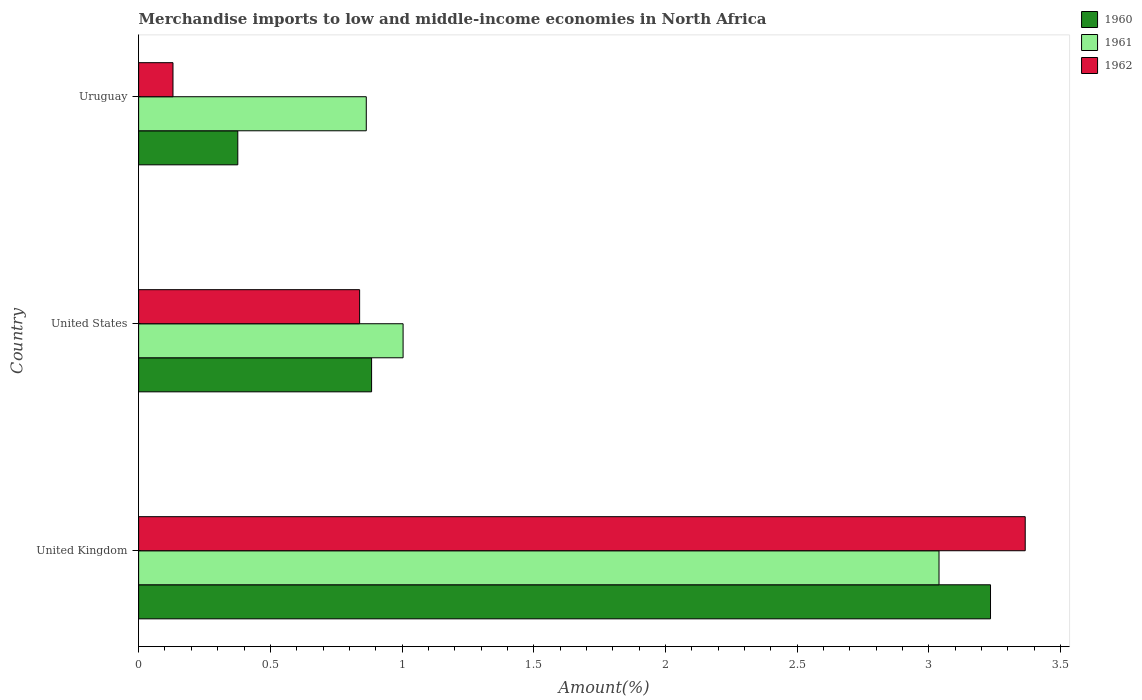How many different coloured bars are there?
Ensure brevity in your answer.  3. Are the number of bars per tick equal to the number of legend labels?
Offer a terse response. Yes. Are the number of bars on each tick of the Y-axis equal?
Provide a short and direct response. Yes. How many bars are there on the 1st tick from the top?
Keep it short and to the point. 3. How many bars are there on the 1st tick from the bottom?
Ensure brevity in your answer.  3. What is the label of the 1st group of bars from the top?
Keep it short and to the point. Uruguay. In how many cases, is the number of bars for a given country not equal to the number of legend labels?
Your response must be concise. 0. What is the percentage of amount earned from merchandise imports in 1962 in Uruguay?
Your answer should be compact. 0.13. Across all countries, what is the maximum percentage of amount earned from merchandise imports in 1962?
Give a very brief answer. 3.37. Across all countries, what is the minimum percentage of amount earned from merchandise imports in 1961?
Give a very brief answer. 0.86. In which country was the percentage of amount earned from merchandise imports in 1961 minimum?
Offer a terse response. Uruguay. What is the total percentage of amount earned from merchandise imports in 1962 in the graph?
Your answer should be compact. 4.33. What is the difference between the percentage of amount earned from merchandise imports in 1962 in United Kingdom and that in United States?
Your answer should be very brief. 2.53. What is the difference between the percentage of amount earned from merchandise imports in 1961 in United States and the percentage of amount earned from merchandise imports in 1962 in Uruguay?
Ensure brevity in your answer.  0.87. What is the average percentage of amount earned from merchandise imports in 1961 per country?
Provide a succinct answer. 1.64. What is the difference between the percentage of amount earned from merchandise imports in 1961 and percentage of amount earned from merchandise imports in 1960 in United Kingdom?
Offer a terse response. -0.2. What is the ratio of the percentage of amount earned from merchandise imports in 1960 in United Kingdom to that in United States?
Provide a short and direct response. 3.66. Is the percentage of amount earned from merchandise imports in 1962 in United Kingdom less than that in Uruguay?
Your answer should be very brief. No. What is the difference between the highest and the second highest percentage of amount earned from merchandise imports in 1960?
Offer a very short reply. 2.35. What is the difference between the highest and the lowest percentage of amount earned from merchandise imports in 1962?
Provide a succinct answer. 3.24. In how many countries, is the percentage of amount earned from merchandise imports in 1960 greater than the average percentage of amount earned from merchandise imports in 1960 taken over all countries?
Keep it short and to the point. 1. Is the sum of the percentage of amount earned from merchandise imports in 1961 in United Kingdom and Uruguay greater than the maximum percentage of amount earned from merchandise imports in 1962 across all countries?
Your answer should be very brief. Yes. How many bars are there?
Your answer should be very brief. 9. How many countries are there in the graph?
Provide a succinct answer. 3. What is the difference between two consecutive major ticks on the X-axis?
Your answer should be compact. 0.5. How many legend labels are there?
Make the answer very short. 3. What is the title of the graph?
Make the answer very short. Merchandise imports to low and middle-income economies in North Africa. Does "2000" appear as one of the legend labels in the graph?
Keep it short and to the point. No. What is the label or title of the X-axis?
Give a very brief answer. Amount(%). What is the Amount(%) in 1960 in United Kingdom?
Keep it short and to the point. 3.23. What is the Amount(%) in 1961 in United Kingdom?
Your response must be concise. 3.04. What is the Amount(%) of 1962 in United Kingdom?
Offer a terse response. 3.37. What is the Amount(%) in 1960 in United States?
Provide a succinct answer. 0.88. What is the Amount(%) of 1961 in United States?
Your response must be concise. 1. What is the Amount(%) of 1962 in United States?
Ensure brevity in your answer.  0.84. What is the Amount(%) of 1960 in Uruguay?
Your answer should be compact. 0.38. What is the Amount(%) of 1961 in Uruguay?
Ensure brevity in your answer.  0.86. What is the Amount(%) of 1962 in Uruguay?
Give a very brief answer. 0.13. Across all countries, what is the maximum Amount(%) of 1960?
Your response must be concise. 3.23. Across all countries, what is the maximum Amount(%) of 1961?
Your response must be concise. 3.04. Across all countries, what is the maximum Amount(%) in 1962?
Keep it short and to the point. 3.37. Across all countries, what is the minimum Amount(%) of 1960?
Offer a very short reply. 0.38. Across all countries, what is the minimum Amount(%) in 1961?
Your response must be concise. 0.86. Across all countries, what is the minimum Amount(%) of 1962?
Keep it short and to the point. 0.13. What is the total Amount(%) of 1960 in the graph?
Give a very brief answer. 4.49. What is the total Amount(%) in 1961 in the graph?
Offer a very short reply. 4.91. What is the total Amount(%) in 1962 in the graph?
Offer a very short reply. 4.33. What is the difference between the Amount(%) in 1960 in United Kingdom and that in United States?
Keep it short and to the point. 2.35. What is the difference between the Amount(%) in 1961 in United Kingdom and that in United States?
Your response must be concise. 2.03. What is the difference between the Amount(%) in 1962 in United Kingdom and that in United States?
Provide a short and direct response. 2.53. What is the difference between the Amount(%) in 1960 in United Kingdom and that in Uruguay?
Your response must be concise. 2.86. What is the difference between the Amount(%) in 1961 in United Kingdom and that in Uruguay?
Keep it short and to the point. 2.17. What is the difference between the Amount(%) of 1962 in United Kingdom and that in Uruguay?
Your answer should be compact. 3.23. What is the difference between the Amount(%) in 1960 in United States and that in Uruguay?
Provide a short and direct response. 0.51. What is the difference between the Amount(%) in 1961 in United States and that in Uruguay?
Provide a short and direct response. 0.14. What is the difference between the Amount(%) of 1962 in United States and that in Uruguay?
Your answer should be very brief. 0.71. What is the difference between the Amount(%) of 1960 in United Kingdom and the Amount(%) of 1961 in United States?
Your answer should be very brief. 2.23. What is the difference between the Amount(%) of 1960 in United Kingdom and the Amount(%) of 1962 in United States?
Your response must be concise. 2.39. What is the difference between the Amount(%) in 1961 in United Kingdom and the Amount(%) in 1962 in United States?
Give a very brief answer. 2.2. What is the difference between the Amount(%) in 1960 in United Kingdom and the Amount(%) in 1961 in Uruguay?
Your answer should be very brief. 2.37. What is the difference between the Amount(%) in 1960 in United Kingdom and the Amount(%) in 1962 in Uruguay?
Provide a short and direct response. 3.1. What is the difference between the Amount(%) of 1961 in United Kingdom and the Amount(%) of 1962 in Uruguay?
Keep it short and to the point. 2.91. What is the difference between the Amount(%) in 1960 in United States and the Amount(%) in 1961 in Uruguay?
Give a very brief answer. 0.02. What is the difference between the Amount(%) in 1960 in United States and the Amount(%) in 1962 in Uruguay?
Keep it short and to the point. 0.75. What is the difference between the Amount(%) of 1961 in United States and the Amount(%) of 1962 in Uruguay?
Offer a very short reply. 0.87. What is the average Amount(%) of 1960 per country?
Your answer should be very brief. 1.5. What is the average Amount(%) of 1961 per country?
Make the answer very short. 1.64. What is the average Amount(%) of 1962 per country?
Your answer should be very brief. 1.44. What is the difference between the Amount(%) of 1960 and Amount(%) of 1961 in United Kingdom?
Provide a short and direct response. 0.2. What is the difference between the Amount(%) in 1960 and Amount(%) in 1962 in United Kingdom?
Your response must be concise. -0.13. What is the difference between the Amount(%) of 1961 and Amount(%) of 1962 in United Kingdom?
Your answer should be very brief. -0.33. What is the difference between the Amount(%) of 1960 and Amount(%) of 1961 in United States?
Provide a short and direct response. -0.12. What is the difference between the Amount(%) of 1960 and Amount(%) of 1962 in United States?
Your answer should be very brief. 0.05. What is the difference between the Amount(%) in 1961 and Amount(%) in 1962 in United States?
Offer a terse response. 0.17. What is the difference between the Amount(%) of 1960 and Amount(%) of 1961 in Uruguay?
Offer a very short reply. -0.49. What is the difference between the Amount(%) of 1960 and Amount(%) of 1962 in Uruguay?
Your answer should be compact. 0.25. What is the difference between the Amount(%) in 1961 and Amount(%) in 1962 in Uruguay?
Your answer should be very brief. 0.73. What is the ratio of the Amount(%) of 1960 in United Kingdom to that in United States?
Give a very brief answer. 3.66. What is the ratio of the Amount(%) in 1961 in United Kingdom to that in United States?
Your response must be concise. 3.03. What is the ratio of the Amount(%) of 1962 in United Kingdom to that in United States?
Keep it short and to the point. 4.01. What is the ratio of the Amount(%) in 1960 in United Kingdom to that in Uruguay?
Keep it short and to the point. 8.59. What is the ratio of the Amount(%) in 1961 in United Kingdom to that in Uruguay?
Your answer should be very brief. 3.52. What is the ratio of the Amount(%) in 1962 in United Kingdom to that in Uruguay?
Your response must be concise. 25.8. What is the ratio of the Amount(%) of 1960 in United States to that in Uruguay?
Your answer should be compact. 2.35. What is the ratio of the Amount(%) of 1961 in United States to that in Uruguay?
Make the answer very short. 1.16. What is the ratio of the Amount(%) in 1962 in United States to that in Uruguay?
Keep it short and to the point. 6.43. What is the difference between the highest and the second highest Amount(%) in 1960?
Your response must be concise. 2.35. What is the difference between the highest and the second highest Amount(%) in 1961?
Give a very brief answer. 2.03. What is the difference between the highest and the second highest Amount(%) of 1962?
Keep it short and to the point. 2.53. What is the difference between the highest and the lowest Amount(%) in 1960?
Give a very brief answer. 2.86. What is the difference between the highest and the lowest Amount(%) of 1961?
Provide a succinct answer. 2.17. What is the difference between the highest and the lowest Amount(%) of 1962?
Make the answer very short. 3.23. 